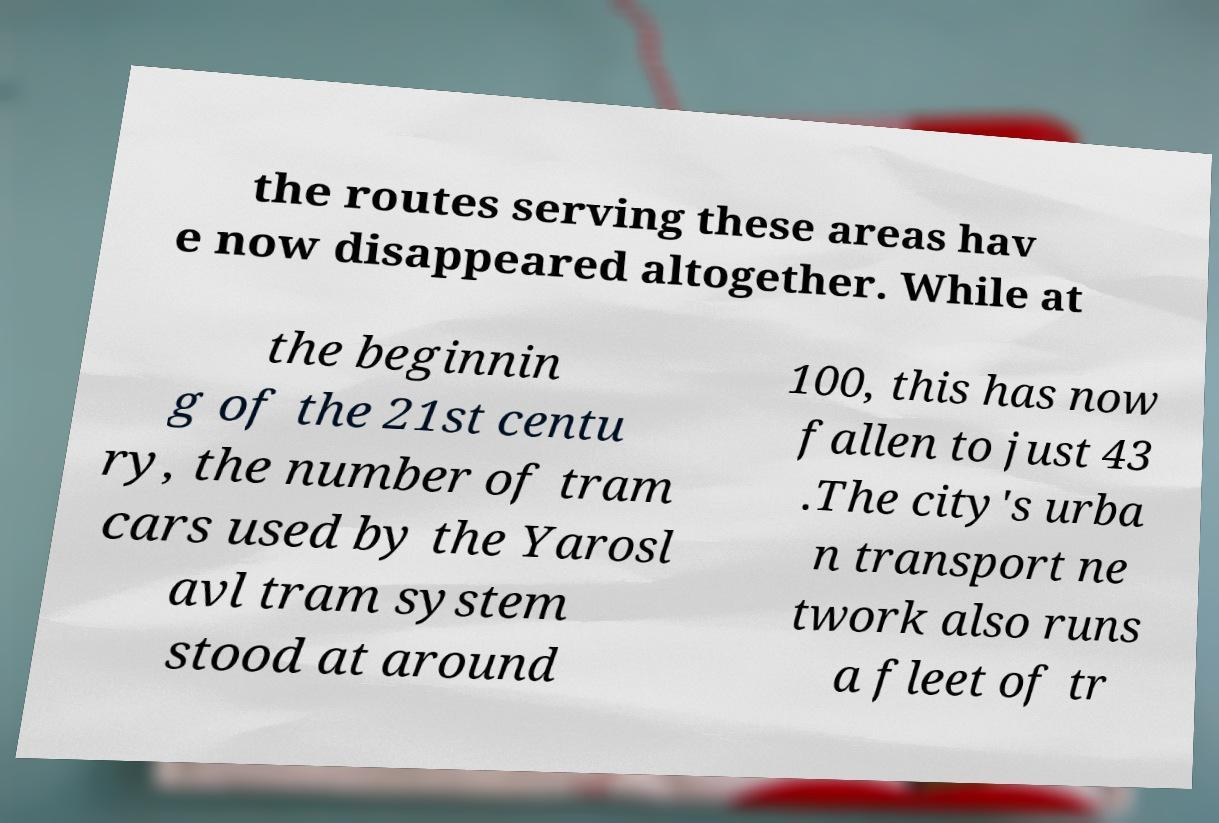There's text embedded in this image that I need extracted. Can you transcribe it verbatim? the routes serving these areas hav e now disappeared altogether. While at the beginnin g of the 21st centu ry, the number of tram cars used by the Yarosl avl tram system stood at around 100, this has now fallen to just 43 .The city's urba n transport ne twork also runs a fleet of tr 